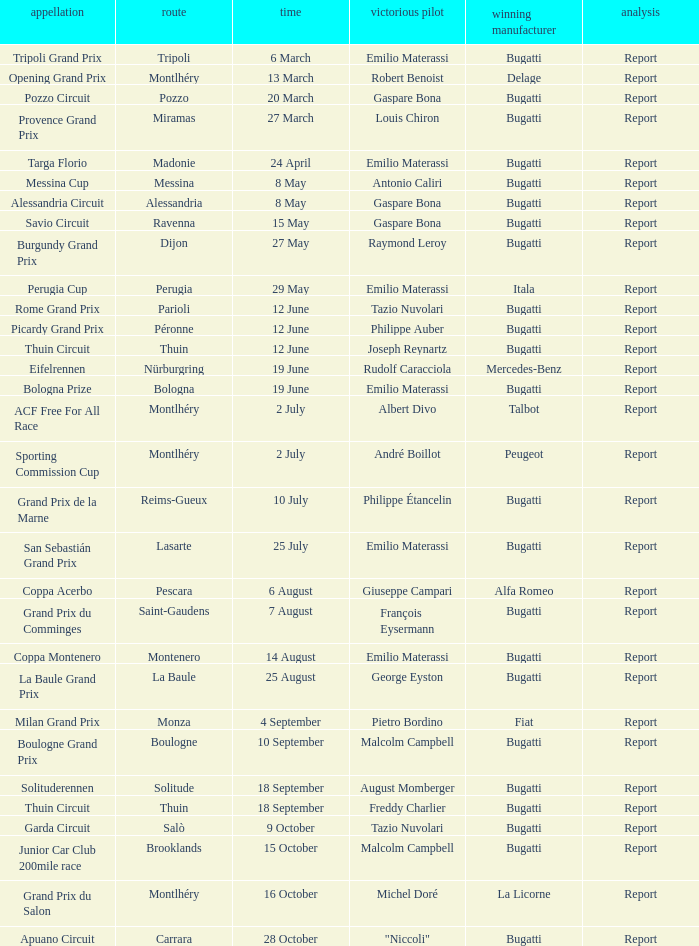Who was the winning constructor at the circuit of parioli? Bugatti. 